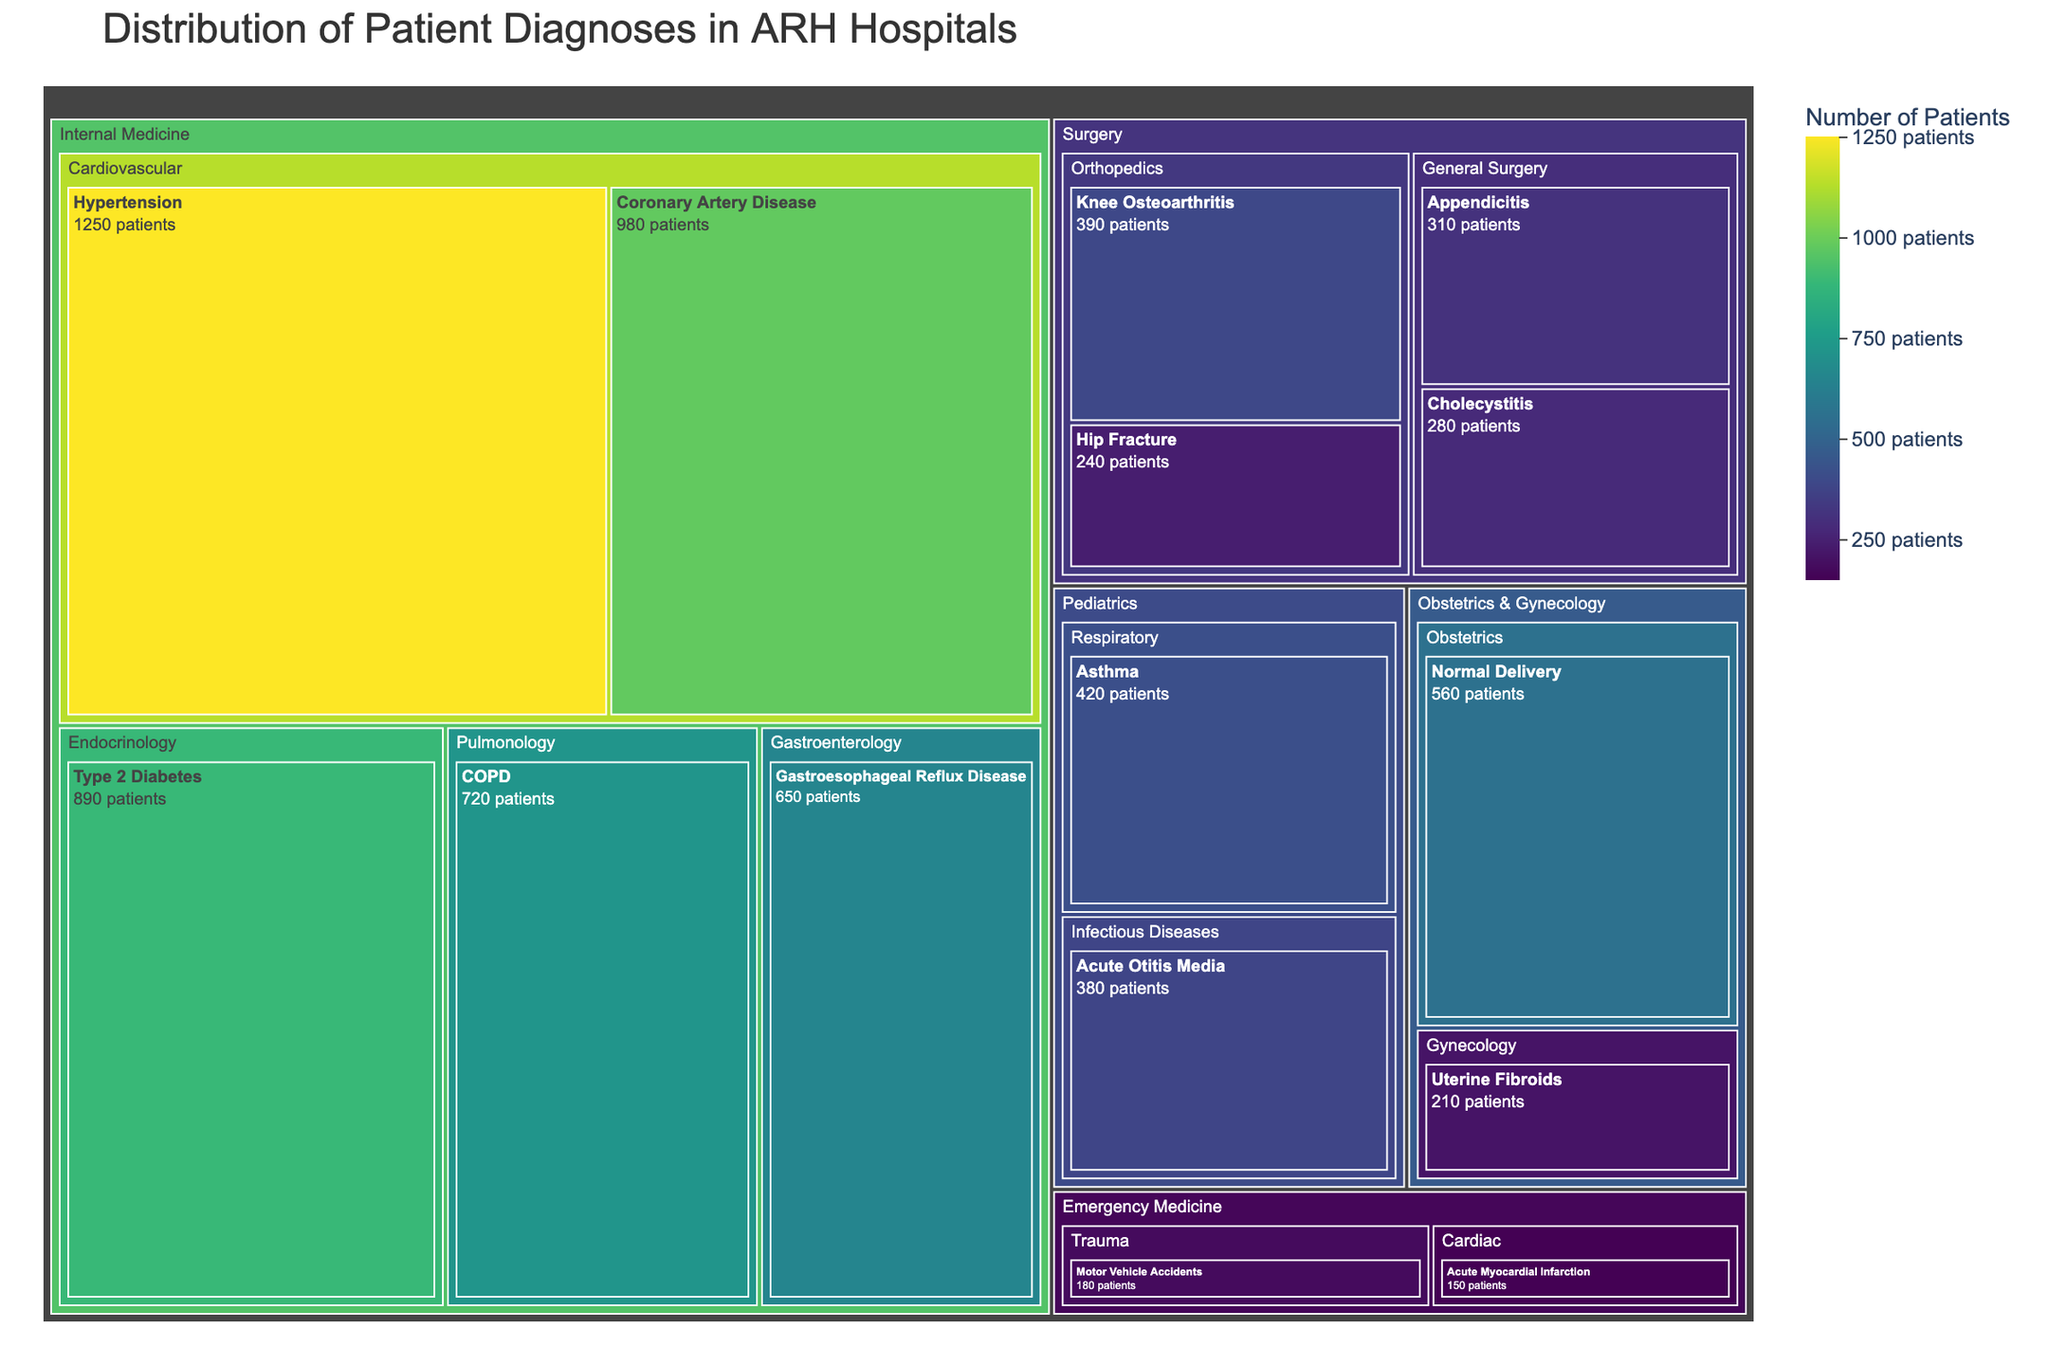What is the most common diagnosis in ARH hospitals? By looking at the largest block in the treemap, it stands out prominently due to its size and color intensity which represents the number of patients. This leads us to identify it as "Hypertension" in the Cardiovascular category under Internal Medicine.
Answer: Hypertension Which specialty has the highest number of patient diagnoses? To determine this, sum up the patient numbers within each specialty block. The specialty with the largest cumulative total is "Internal Medicine."
Answer: Internal Medicine What is the total number of patients diagnosed with Endocrinology-related issues? Look at the size of blocks within the Endocrinology category. The block for "Type 2 Diabetes" under Endocrinology lists 890 patients. Since there is only one diagnosis here, that is the total number.
Answer: 890 How many patients were diagnosed with respiratory issues in Pediatrics? From the treemap, locate the Pediatrics specialty and then the Respiratory category within it. The block for "Asthma" under this category shows 420 patients.
Answer: 420 Which diagnosis has more patients: COPD or GERD? Compare the sizes of the "COPD" and "Gastroesophageal Reflux Disease" (GERD) blocks within Internal Medicine. "COPD" has 720 patients while "Gastroesophageal Reflux Disease" has 650 patients.
Answer: COPD What are the total number of patients diagnosed in the Surgery specialty? Sum the number of patients for all diagnoses under the Surgery specialty: Appendicitis (310) + Cholecystitis (280) + Hip Fracture (240) + Knee Osteoarthritis (390) = 1220.
Answer: 1220 What is the least common diagnosis in ARH hospitals? Locate the smallest block in the treemap, which is "Acute Myocardial Infarction" under the Cardiac category within Emergency Medicine, with 150 patients.
Answer: Acute Myocardial Infarction Which category within Internal Medicine has the smallest number of patients? Within Internal Medicine, compare the total patient numbers of each category. Pulmonology has 720 patients (COPD only), which is less than Gastroenterology (650) and Endocrinology (890). So, Gastroenterology is the smallest category within Internal Medicine since it has only one relevant category component.
Answer: Gastroenterology Which has more patients: Normal Delivery in Obstetrics & Gynecology or Motor Vehicle Accidents in Emergency Medicine? Compare the sizes of the blocks. "Normal Delivery" in Obstetrics has 560 patients, while "Motor Vehicle Accidents" in Emergency Medicine has 180 patients.
Answer: Normal Delivery 